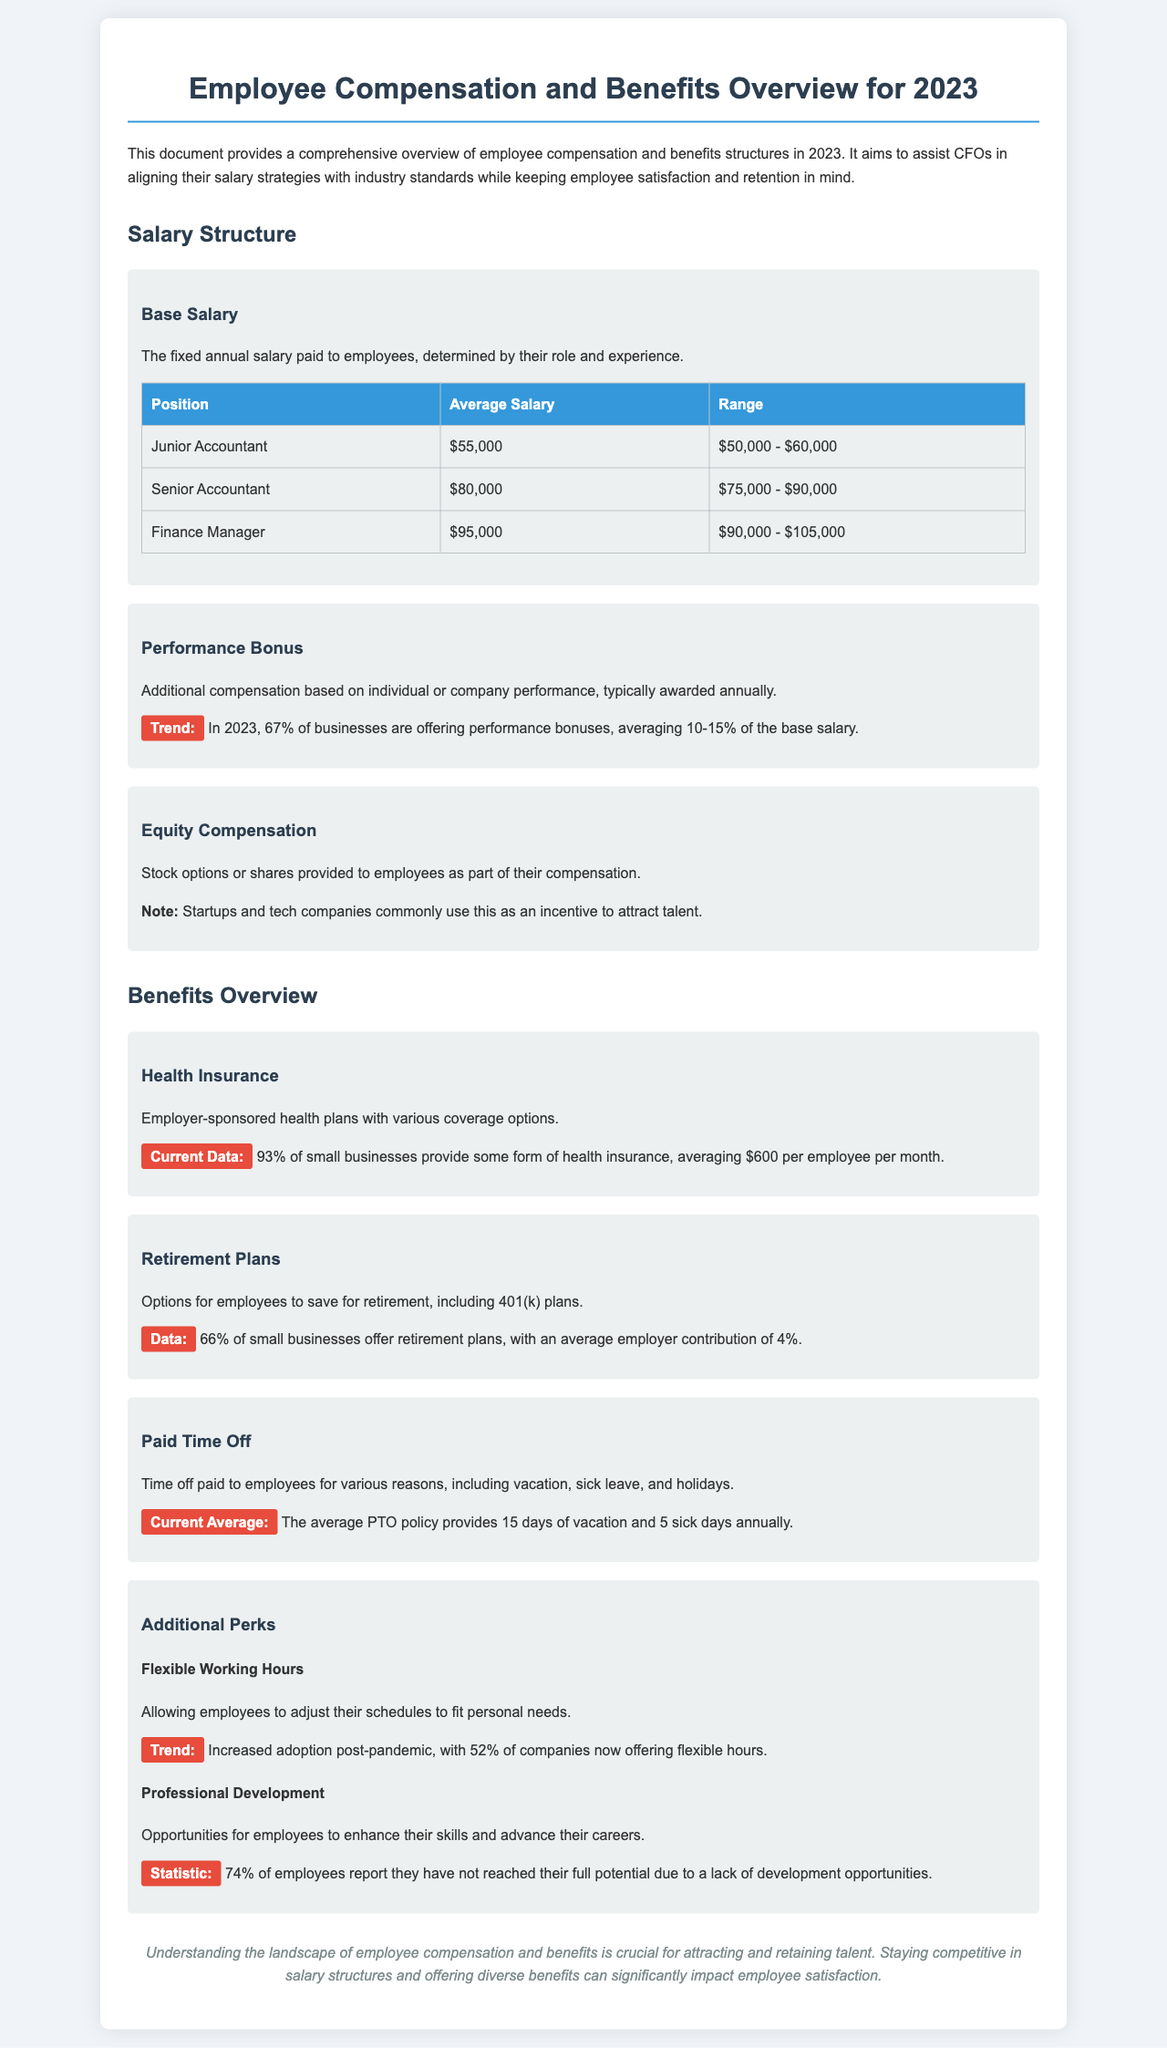What is the average salary for a Junior Accountant? The document states that the average salary for a Junior Accountant is $55,000.
Answer: $55,000 What percentage of businesses offer performance bonuses? According to the document, 67% of businesses are offering performance bonuses.
Answer: 67% What is the average employer contribution for retirement plans? The document mentions that the average employer contribution for retirement plans is 4%.
Answer: 4% How many days of vacation does the average PTO policy provide? The average PTO policy provides 15 days of vacation annually, as noted in the document.
Answer: 15 days What is the average monthly cost of health insurance per employee? The document states the average monthly cost of health insurance per employee is $600.
Answer: $600 What is the trend for flexible working hours post-pandemic? The document highlights that there is increased adoption of flexible working hours, with 52% of companies now offering it.
Answer: 52% What role is typically associated with an average salary of $95,000? The document specifies that a Finance Manager typically has an average salary of $95,000.
Answer: Finance Manager What is a common benefit provided by 93% of small businesses? The document indicates that 93% of small businesses provide some form of health insurance.
Answer: Health Insurance How many sick days are provided on average in the PTO policy? The document states the average PTO policy includes 5 sick days annually.
Answer: 5 sick days 